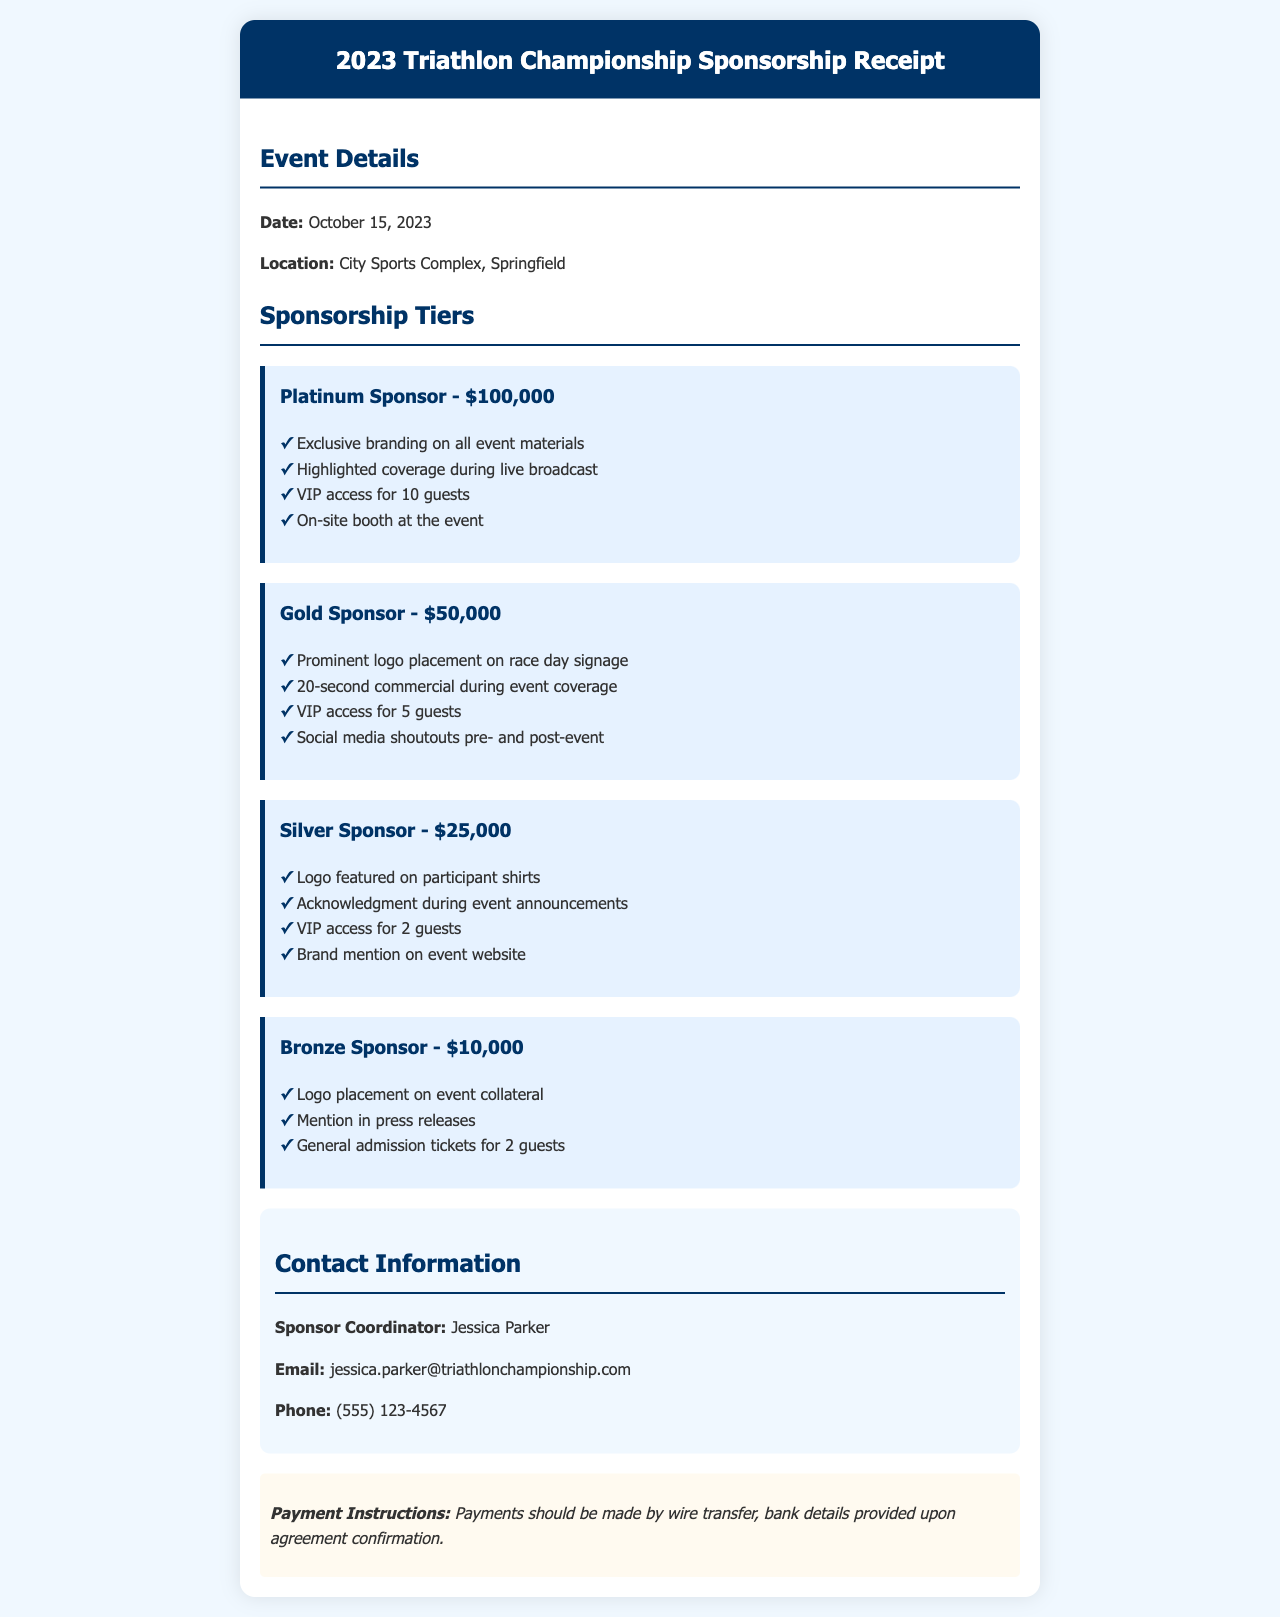what is the date of the event? The date of the event is specified in the document as October 15, 2023.
Answer: October 15, 2023 what is the location of the triathlon? The location of the triathlon is provided as City Sports Complex, Springfield.
Answer: City Sports Complex, Springfield who is the Sponsor Coordinator? The document states that the Sponsor Coordinator's name is Jessica Parker.
Answer: Jessica Parker how much is the Platinum Sponsor tier? The monetary commitment for the Platinum Sponsor tier is listed as $100,000.
Answer: $100,000 what benefits does a Gold Sponsor receive? Benefits for a Gold Sponsor can be found by looking at the tier's details, which include a 20-second commercial during event coverage.
Answer: 20-second commercial during event coverage if a company chooses the Silver Sponsor tier, how many VIP guests can they invite? The document mentions that the Silver Sponsor tier provides VIP access for 2 guests.
Answer: 2 guests what payment method is specified in the document? The document outlines that payments should be made by wire transfer.
Answer: wire transfer which company would receive exclusive branding on all event materials? The document indicates that the Platinum Sponsor would receive exclusive branding on all event materials.
Answer: Platinum Sponsor what type of document is this? The content of the document is summarizing a sponsorship agreement.
Answer: sponsorship agreement 